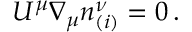<formula> <loc_0><loc_0><loc_500><loc_500>U ^ { \mu } { \nabla } _ { \mu } n _ { ( i ) } ^ { \nu } = 0 \, .</formula> 